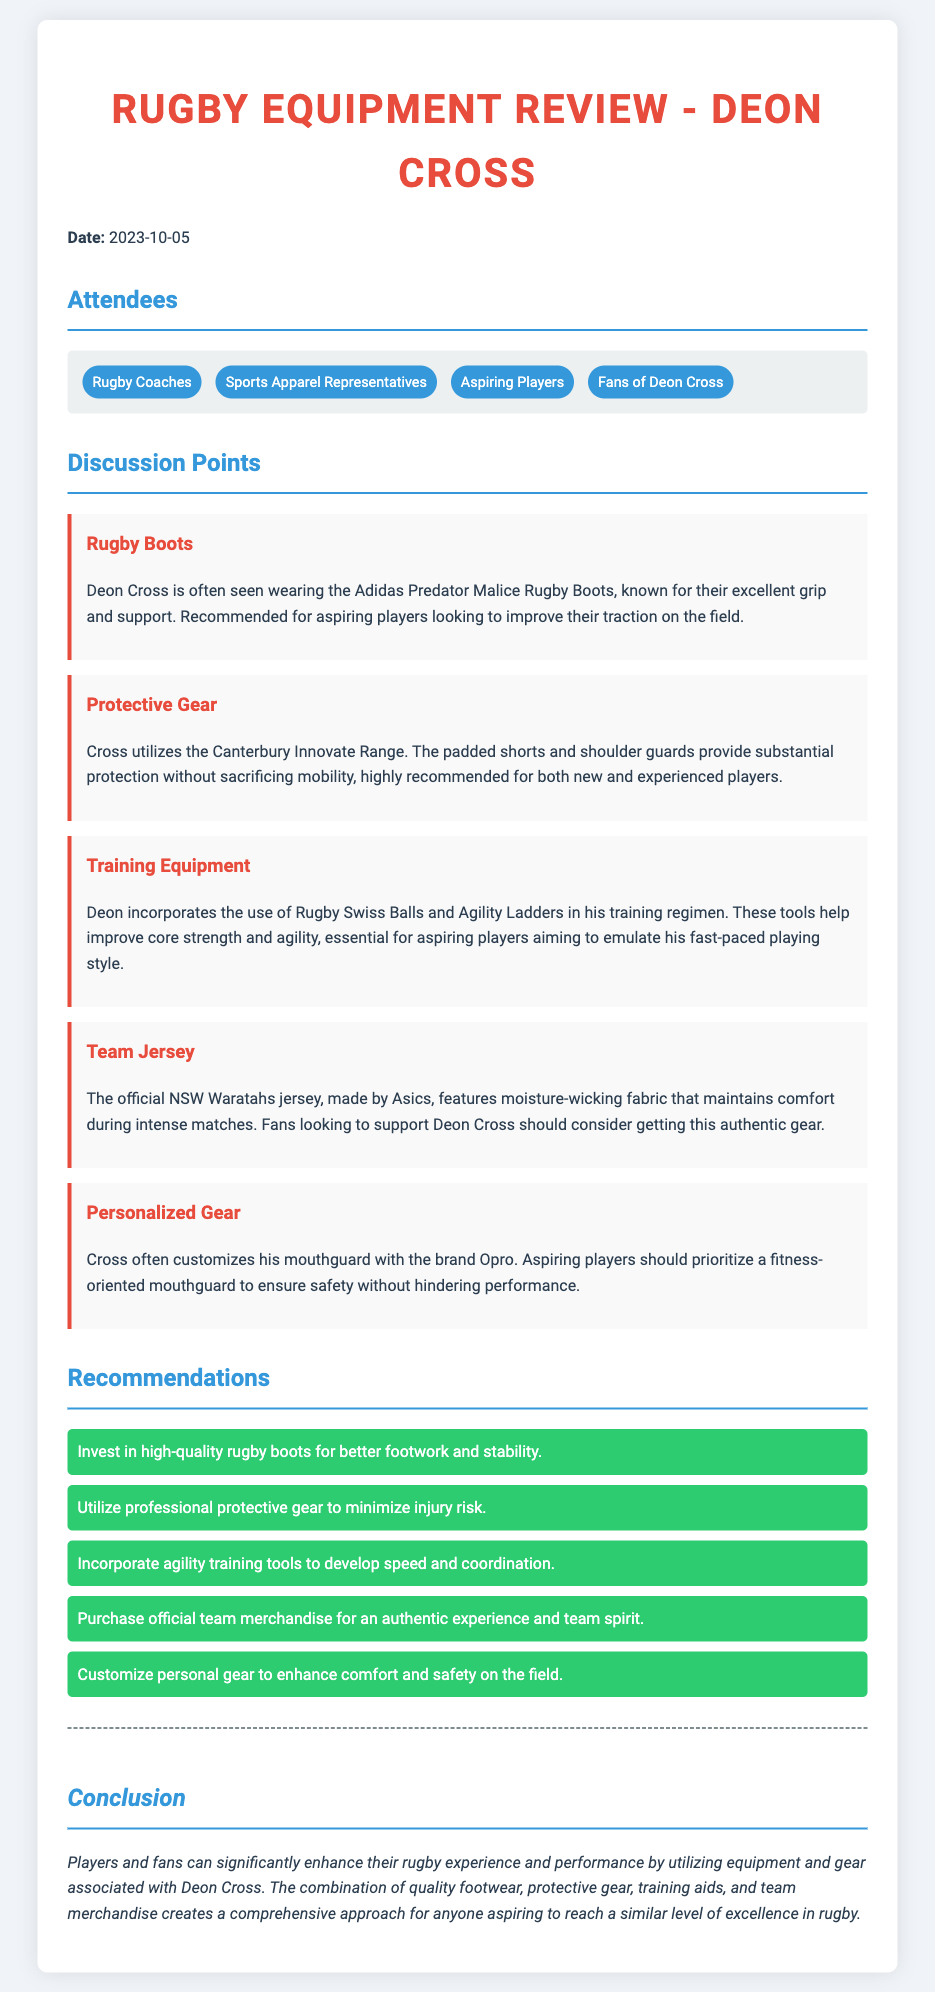What date was the meeting held? The meeting date is clearly mentioned at the beginning of the document.
Answer: 2023-10-05 Who are the attendees? The attendees are listed in a dedicated section of the document.
Answer: Rugby Coaches, Sports Apparel Representatives, Aspiring Players, Fans of Deon Cross What type of rugby boots does Deon Cross wear? The document specifies the brand and model of the boots.
Answer: Adidas Predator Malice Rugby Boots What protective gear does Deon Cross utilize? The specific range of protective gear used by Deon Cross is mentioned.
Answer: Canterbury Innovate Range What is one of the training tools Deon Cross incorporates? The document lists specific training equipment he uses.
Answer: Rugby Swiss Balls Why should aspiring players consider high-quality rugby boots? The reasoning includes benefits stated in the discussion point about boots.
Answer: Better footwork and stability Which jersey does Deon Cross wear? The brand and details about the jersey are provided in the discussion points.
Answer: NSW Waratahs jersey What is a recommended safety gear for aspiring players? The type of customized gear that promotes safety is noted in the document.
Answer: Fitness-oriented mouthguard How does the document recommend players enhance their rugby experience? The conclusion summarizes the key points and combines different aspects of equipment.
Answer: Utilizing equipment and gear associated with Deon Cross 